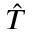Convert formula to latex. <formula><loc_0><loc_0><loc_500><loc_500>\hat { T }</formula> 